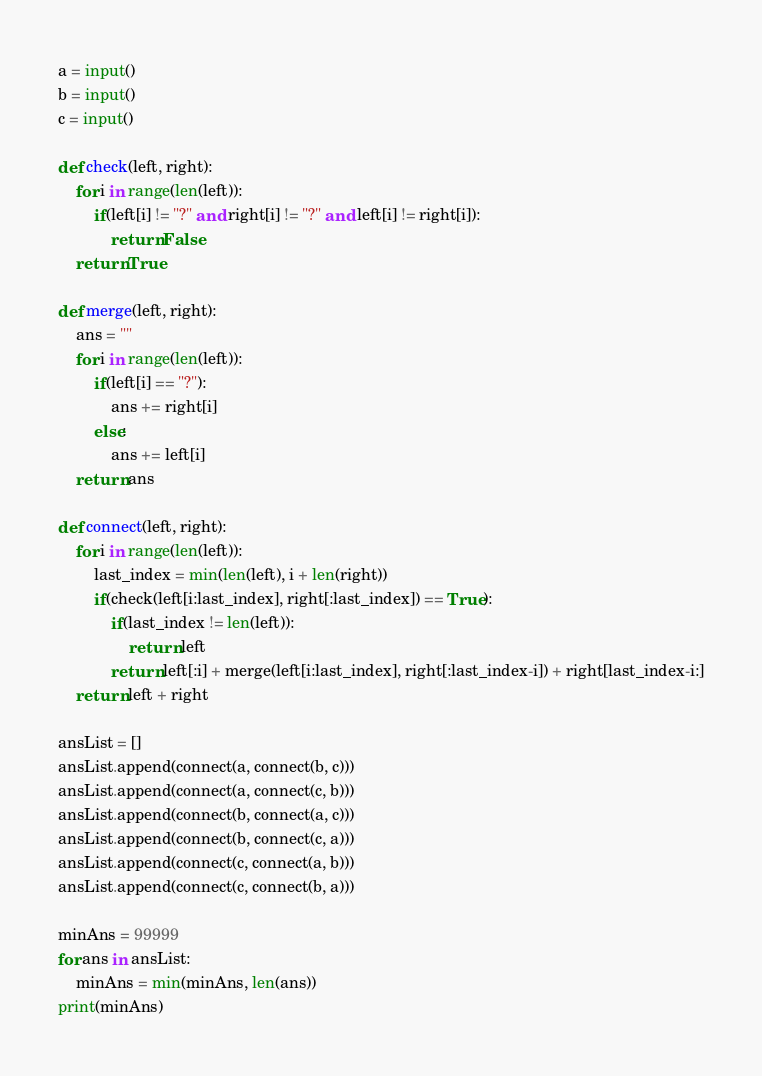Convert code to text. <code><loc_0><loc_0><loc_500><loc_500><_Python_>a = input()
b = input()
c = input()

def check(left, right):
    for i in range(len(left)):
        if(left[i] != "?" and right[i] != "?" and left[i] != right[i]):
            return False
    return True

def merge(left, right):
    ans = ""
    for i in range(len(left)):
        if(left[i] == "?"):
            ans += right[i]
        else:
            ans += left[i]
    return ans

def connect(left, right):
    for i in range(len(left)):
        last_index = min(len(left), i + len(right))
        if(check(left[i:last_index], right[:last_index]) == True):
            if(last_index != len(left)):
                return left
            return left[:i] + merge(left[i:last_index], right[:last_index-i]) + right[last_index-i:]
    return left + right    

ansList = []
ansList.append(connect(a, connect(b, c)))
ansList.append(connect(a, connect(c, b)))
ansList.append(connect(b, connect(a, c)))
ansList.append(connect(b, connect(c, a)))
ansList.append(connect(c, connect(a, b)))
ansList.append(connect(c, connect(b, a)))

minAns = 99999
for ans in ansList:
    minAns = min(minAns, len(ans))
print(minAns)</code> 